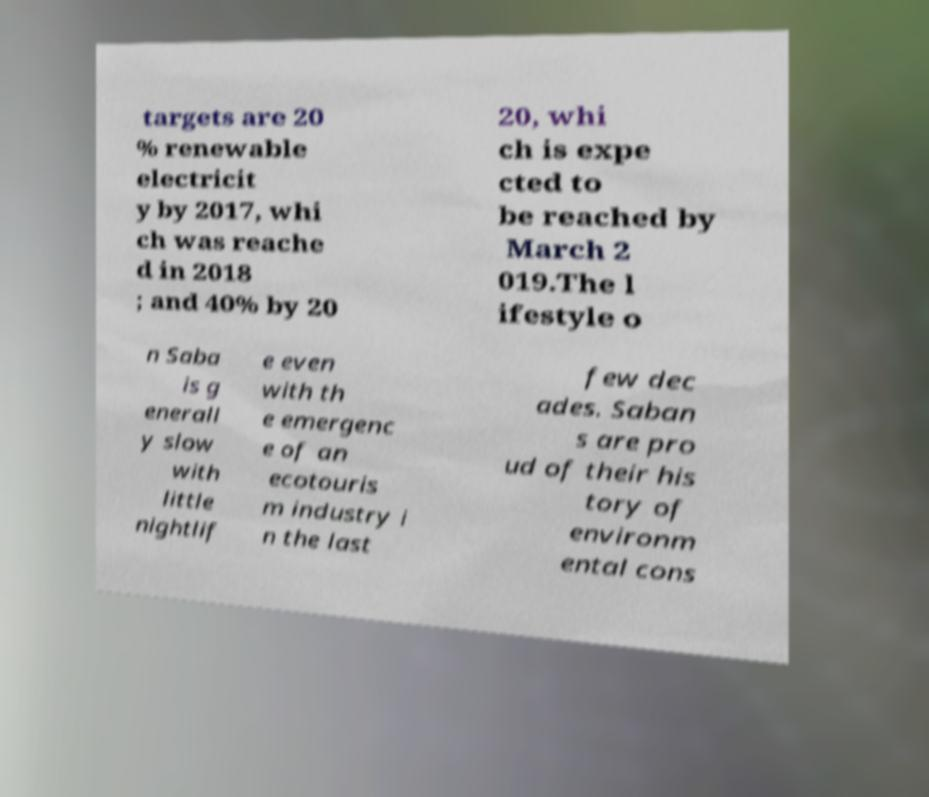Please read and relay the text visible in this image. What does it say? targets are 20 % renewable electricit y by 2017, whi ch was reache d in 2018 ; and 40% by 20 20, whi ch is expe cted to be reached by March 2 019.The l ifestyle o n Saba is g enerall y slow with little nightlif e even with th e emergenc e of an ecotouris m industry i n the last few dec ades. Saban s are pro ud of their his tory of environm ental cons 